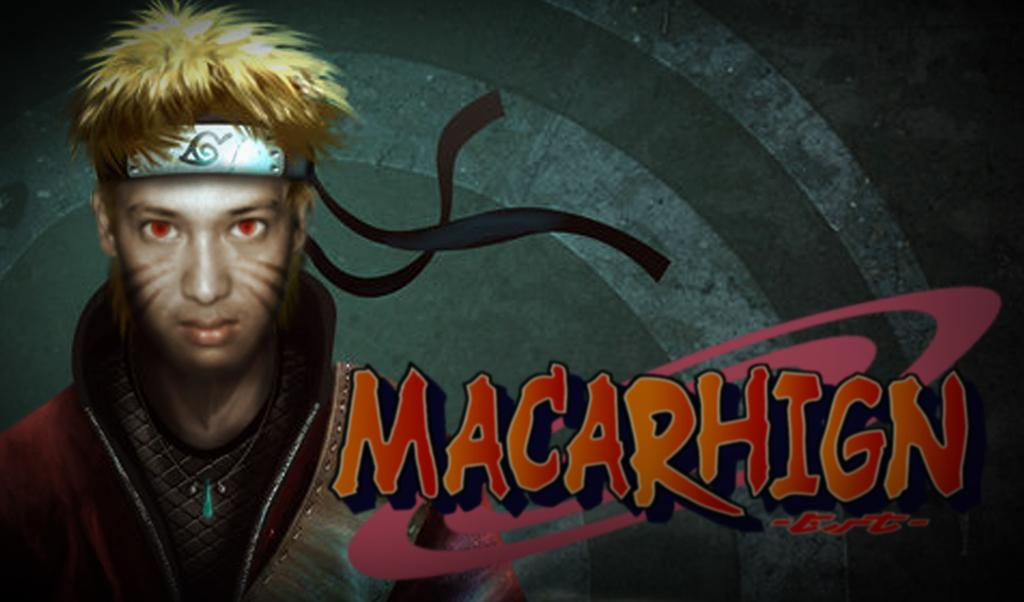What type of image is depicted in the picture? There is an animated picture of a person in the image. What can be seen on the person in the image? The person is wearing clothes and a neck chain. What type of furniture is visible in the image? There is no furniture present in the image; it features an animated person wearing clothes and a neck chain. What flavor of jam is being consumed by the person in the image? There is no jam present in the image; the person is not shown consuming any food or drink. 